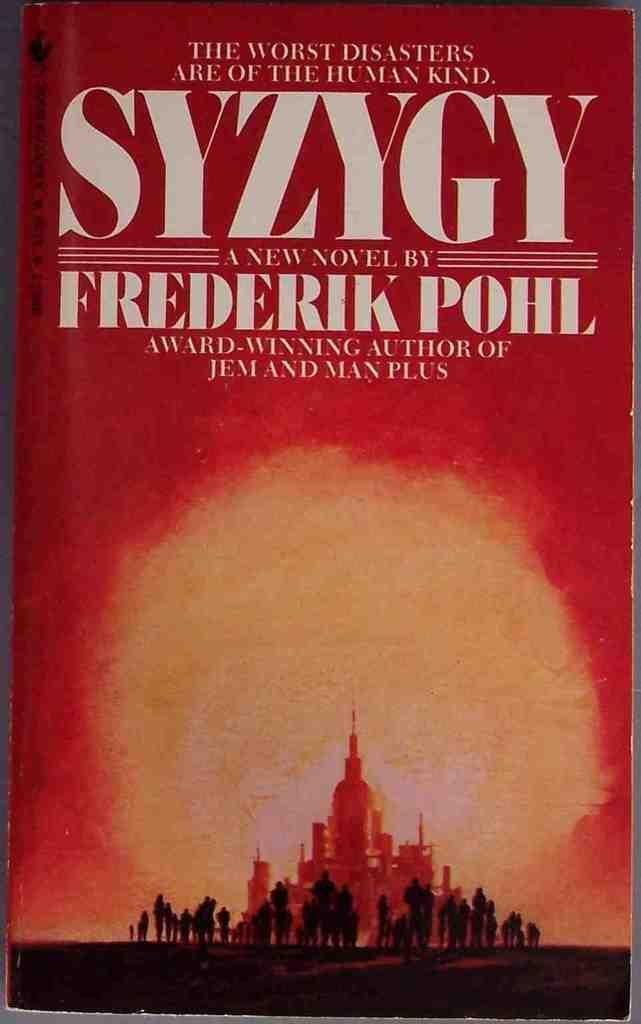<image>
Provide a brief description of the given image. A book that is red by Frederik Pohl. 